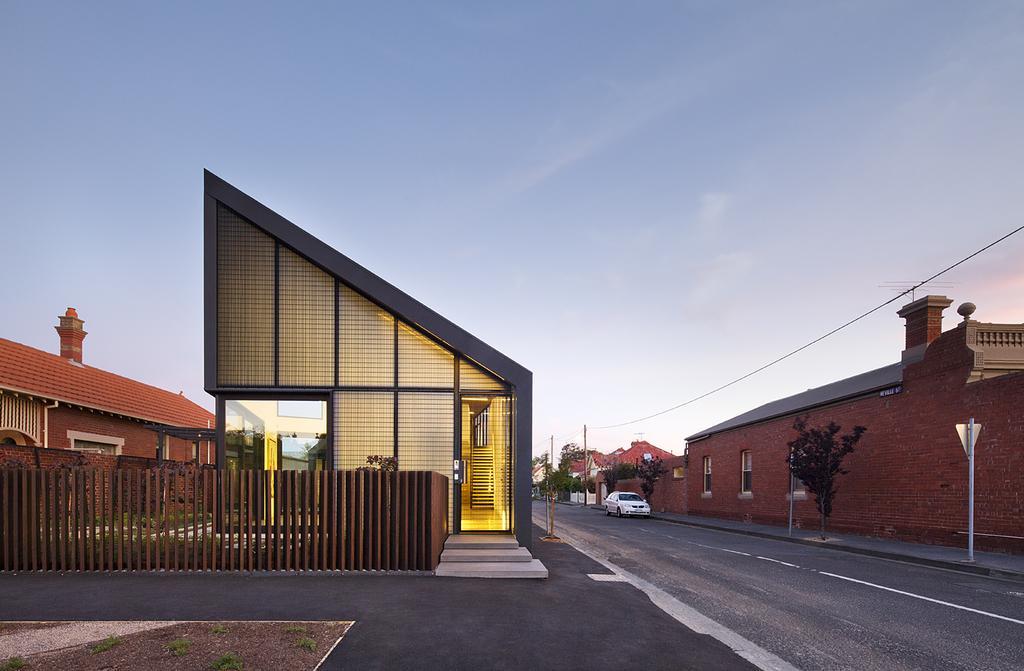How would you summarize this image in a sentence or two? On the right side of the image there is a road with a car. Behind the car there is a footpath with poles and trees. Behind that there is a wall with windows and roof. On the left side of the image there is a fencing. Behind the fencing there are houses with roofs, walls, steps and windows. At the top of the image there is a sky. 